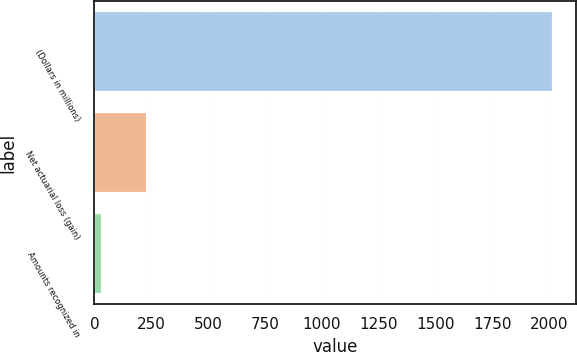Convert chart to OTSL. <chart><loc_0><loc_0><loc_500><loc_500><bar_chart><fcel>(Dollars in millions)<fcel>Net actuarial loss (gain)<fcel>Amounts recognized in<nl><fcel>2016<fcel>230.4<fcel>32<nl></chart> 